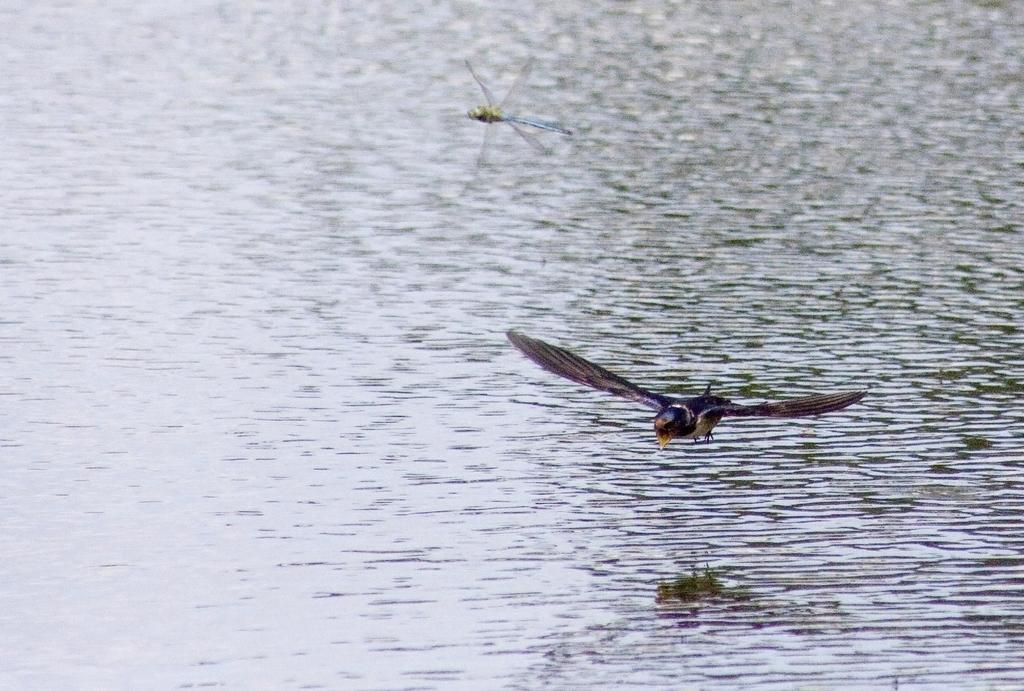What type of insect can be seen in the image? There is a dragonfly in the image. What other animal is present in the image? There is a bird in the image. How is the bird positioned in the image? The bird is flying on the water surface. What type of berry is being used as a comfort item for the bird in the image? There is no berry present in the image, and the bird is not using any comfort item. 